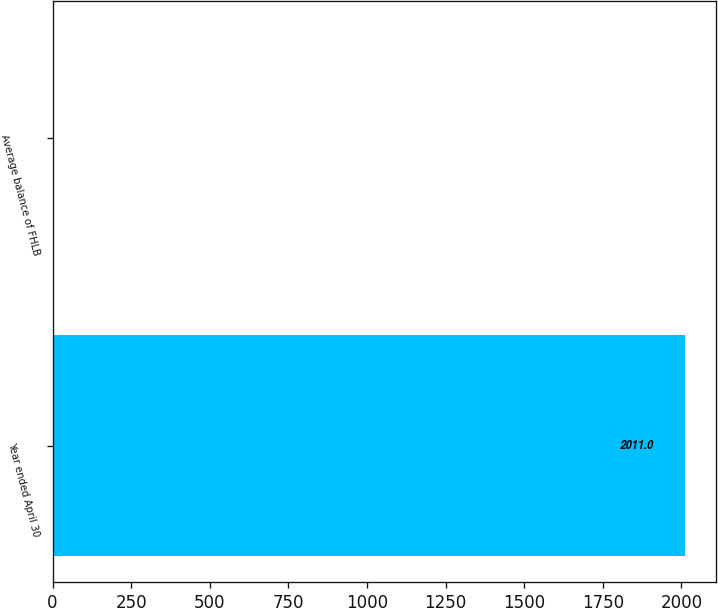Convert chart to OTSL. <chart><loc_0><loc_0><loc_500><loc_500><bar_chart><fcel>Year ended April 30<fcel>Average balance of FHLB<nl><fcel>2011<fcel>2.1<nl></chart> 